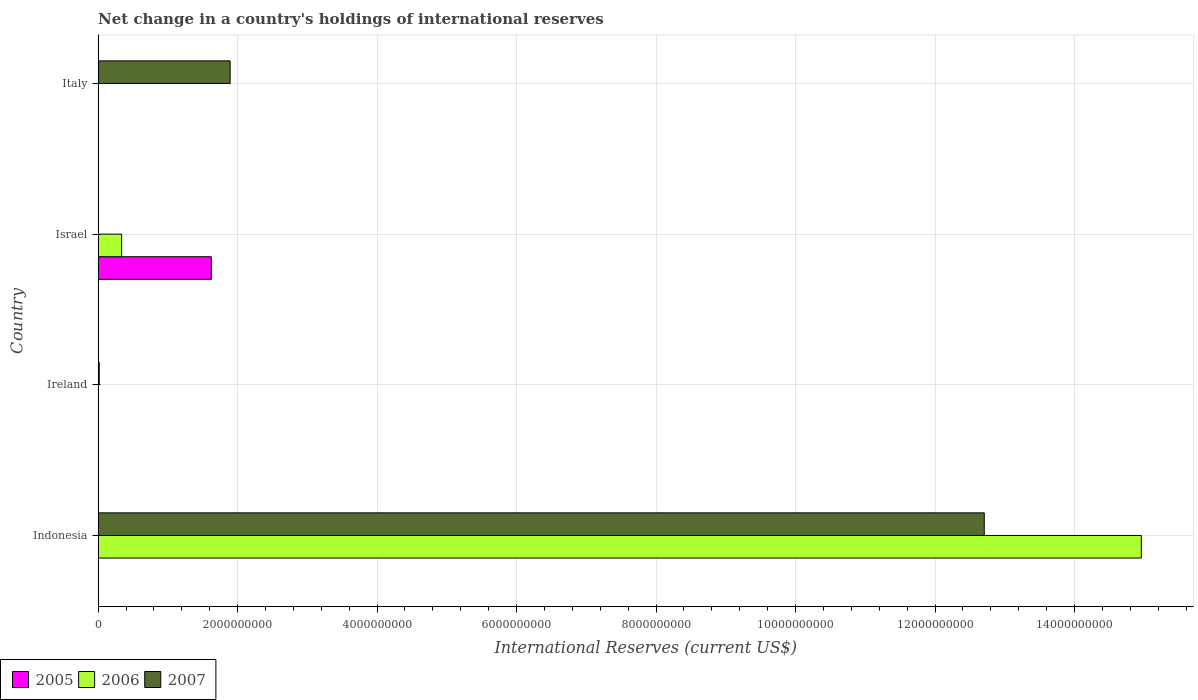How many different coloured bars are there?
Offer a very short reply. 3. Are the number of bars per tick equal to the number of legend labels?
Your answer should be compact. No. How many bars are there on the 2nd tick from the top?
Your answer should be compact. 2. What is the label of the 4th group of bars from the top?
Provide a short and direct response. Indonesia. What is the international reserves in 2006 in Israel?
Ensure brevity in your answer.  3.37e+08. Across all countries, what is the maximum international reserves in 2005?
Your answer should be compact. 1.62e+09. What is the total international reserves in 2007 in the graph?
Offer a terse response. 1.46e+1. What is the difference between the international reserves in 2007 in Indonesia and that in Ireland?
Provide a succinct answer. 1.27e+1. What is the difference between the international reserves in 2005 in Israel and the international reserves in 2007 in Indonesia?
Offer a terse response. -1.11e+1. What is the average international reserves in 2005 per country?
Keep it short and to the point. 4.06e+08. What is the difference between the international reserves in 2005 and international reserves in 2006 in Israel?
Provide a succinct answer. 1.29e+09. What is the ratio of the international reserves in 2006 in Indonesia to that in Israel?
Your response must be concise. 44.36. What is the difference between the highest and the second highest international reserves in 2007?
Give a very brief answer. 1.08e+1. What is the difference between the highest and the lowest international reserves in 2005?
Provide a short and direct response. 1.62e+09. Is it the case that in every country, the sum of the international reserves in 2005 and international reserves in 2006 is greater than the international reserves in 2007?
Your answer should be compact. No. How many bars are there?
Keep it short and to the point. 6. Are the values on the major ticks of X-axis written in scientific E-notation?
Make the answer very short. No. Does the graph contain any zero values?
Keep it short and to the point. Yes. Does the graph contain grids?
Keep it short and to the point. Yes. How many legend labels are there?
Offer a very short reply. 3. How are the legend labels stacked?
Your response must be concise. Horizontal. What is the title of the graph?
Offer a terse response. Net change in a country's holdings of international reserves. What is the label or title of the X-axis?
Provide a short and direct response. International Reserves (current US$). What is the International Reserves (current US$) of 2006 in Indonesia?
Provide a succinct answer. 1.50e+1. What is the International Reserves (current US$) in 2007 in Indonesia?
Ensure brevity in your answer.  1.27e+1. What is the International Reserves (current US$) in 2005 in Ireland?
Ensure brevity in your answer.  0. What is the International Reserves (current US$) of 2006 in Ireland?
Your answer should be compact. 0. What is the International Reserves (current US$) of 2007 in Ireland?
Your answer should be very brief. 1.60e+07. What is the International Reserves (current US$) in 2005 in Israel?
Make the answer very short. 1.62e+09. What is the International Reserves (current US$) in 2006 in Israel?
Your answer should be compact. 3.37e+08. What is the International Reserves (current US$) of 2007 in Israel?
Ensure brevity in your answer.  0. What is the International Reserves (current US$) of 2005 in Italy?
Make the answer very short. 0. What is the International Reserves (current US$) of 2006 in Italy?
Your answer should be compact. 0. What is the International Reserves (current US$) of 2007 in Italy?
Your response must be concise. 1.89e+09. Across all countries, what is the maximum International Reserves (current US$) in 2005?
Offer a very short reply. 1.62e+09. Across all countries, what is the maximum International Reserves (current US$) of 2006?
Your response must be concise. 1.50e+1. Across all countries, what is the maximum International Reserves (current US$) of 2007?
Keep it short and to the point. 1.27e+1. Across all countries, what is the minimum International Reserves (current US$) of 2005?
Make the answer very short. 0. Across all countries, what is the minimum International Reserves (current US$) in 2006?
Your answer should be compact. 0. What is the total International Reserves (current US$) in 2005 in the graph?
Keep it short and to the point. 1.62e+09. What is the total International Reserves (current US$) in 2006 in the graph?
Give a very brief answer. 1.53e+1. What is the total International Reserves (current US$) in 2007 in the graph?
Offer a terse response. 1.46e+1. What is the difference between the International Reserves (current US$) in 2007 in Indonesia and that in Ireland?
Keep it short and to the point. 1.27e+1. What is the difference between the International Reserves (current US$) in 2006 in Indonesia and that in Israel?
Your answer should be very brief. 1.46e+1. What is the difference between the International Reserves (current US$) in 2007 in Indonesia and that in Italy?
Offer a terse response. 1.08e+1. What is the difference between the International Reserves (current US$) of 2007 in Ireland and that in Italy?
Your answer should be very brief. -1.88e+09. What is the difference between the International Reserves (current US$) of 2006 in Indonesia and the International Reserves (current US$) of 2007 in Ireland?
Provide a succinct answer. 1.49e+1. What is the difference between the International Reserves (current US$) of 2006 in Indonesia and the International Reserves (current US$) of 2007 in Italy?
Provide a succinct answer. 1.31e+1. What is the difference between the International Reserves (current US$) in 2005 in Israel and the International Reserves (current US$) in 2007 in Italy?
Offer a terse response. -2.70e+08. What is the difference between the International Reserves (current US$) in 2006 in Israel and the International Reserves (current US$) in 2007 in Italy?
Offer a very short reply. -1.56e+09. What is the average International Reserves (current US$) in 2005 per country?
Provide a succinct answer. 4.06e+08. What is the average International Reserves (current US$) of 2006 per country?
Provide a succinct answer. 3.82e+09. What is the average International Reserves (current US$) of 2007 per country?
Give a very brief answer. 3.65e+09. What is the difference between the International Reserves (current US$) in 2006 and International Reserves (current US$) in 2007 in Indonesia?
Ensure brevity in your answer.  2.25e+09. What is the difference between the International Reserves (current US$) in 2005 and International Reserves (current US$) in 2006 in Israel?
Provide a short and direct response. 1.29e+09. What is the ratio of the International Reserves (current US$) of 2007 in Indonesia to that in Ireland?
Your response must be concise. 795.92. What is the ratio of the International Reserves (current US$) in 2006 in Indonesia to that in Israel?
Your answer should be very brief. 44.36. What is the ratio of the International Reserves (current US$) in 2007 in Indonesia to that in Italy?
Your response must be concise. 6.71. What is the ratio of the International Reserves (current US$) in 2007 in Ireland to that in Italy?
Provide a succinct answer. 0.01. What is the difference between the highest and the second highest International Reserves (current US$) of 2007?
Give a very brief answer. 1.08e+1. What is the difference between the highest and the lowest International Reserves (current US$) of 2005?
Provide a short and direct response. 1.62e+09. What is the difference between the highest and the lowest International Reserves (current US$) of 2006?
Ensure brevity in your answer.  1.50e+1. What is the difference between the highest and the lowest International Reserves (current US$) of 2007?
Your answer should be very brief. 1.27e+1. 